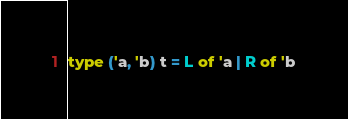Convert code to text. <code><loc_0><loc_0><loc_500><loc_500><_OCaml_>type ('a, 'b) t = L of 'a | R of 'b
</code> 